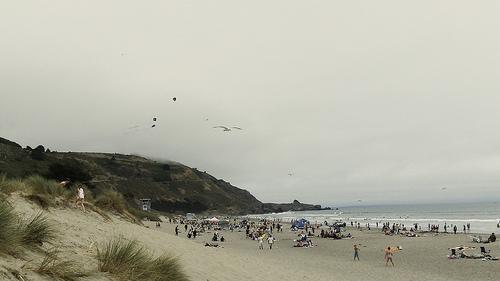How many birds are there?
Give a very brief answer. 1. How many people are up on the hill?
Give a very brief answer. 2. 